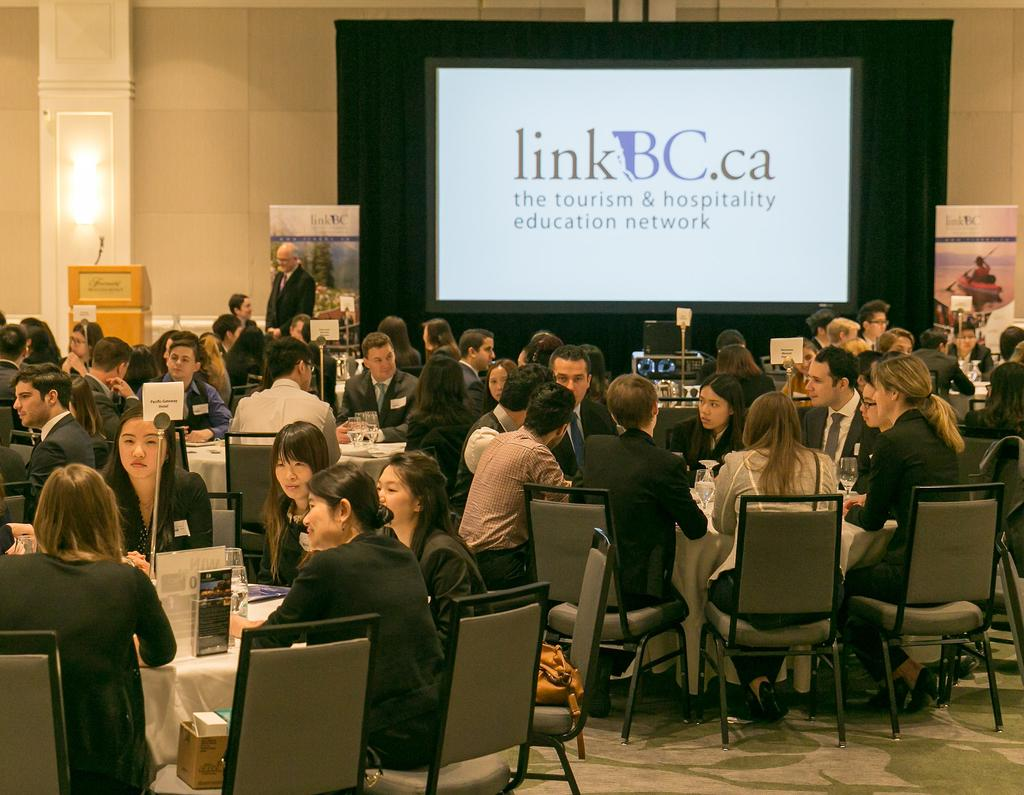What are the people in the image doing? People are sitting at a table in the image. What can be seen on the table? There is a glass on the table. What is present in the background of the image? There is a screen and a wall in the image. Can you see a key hanging from the wall in the image? There is no key visible in the image; only a screen and a wall are present in the background. 